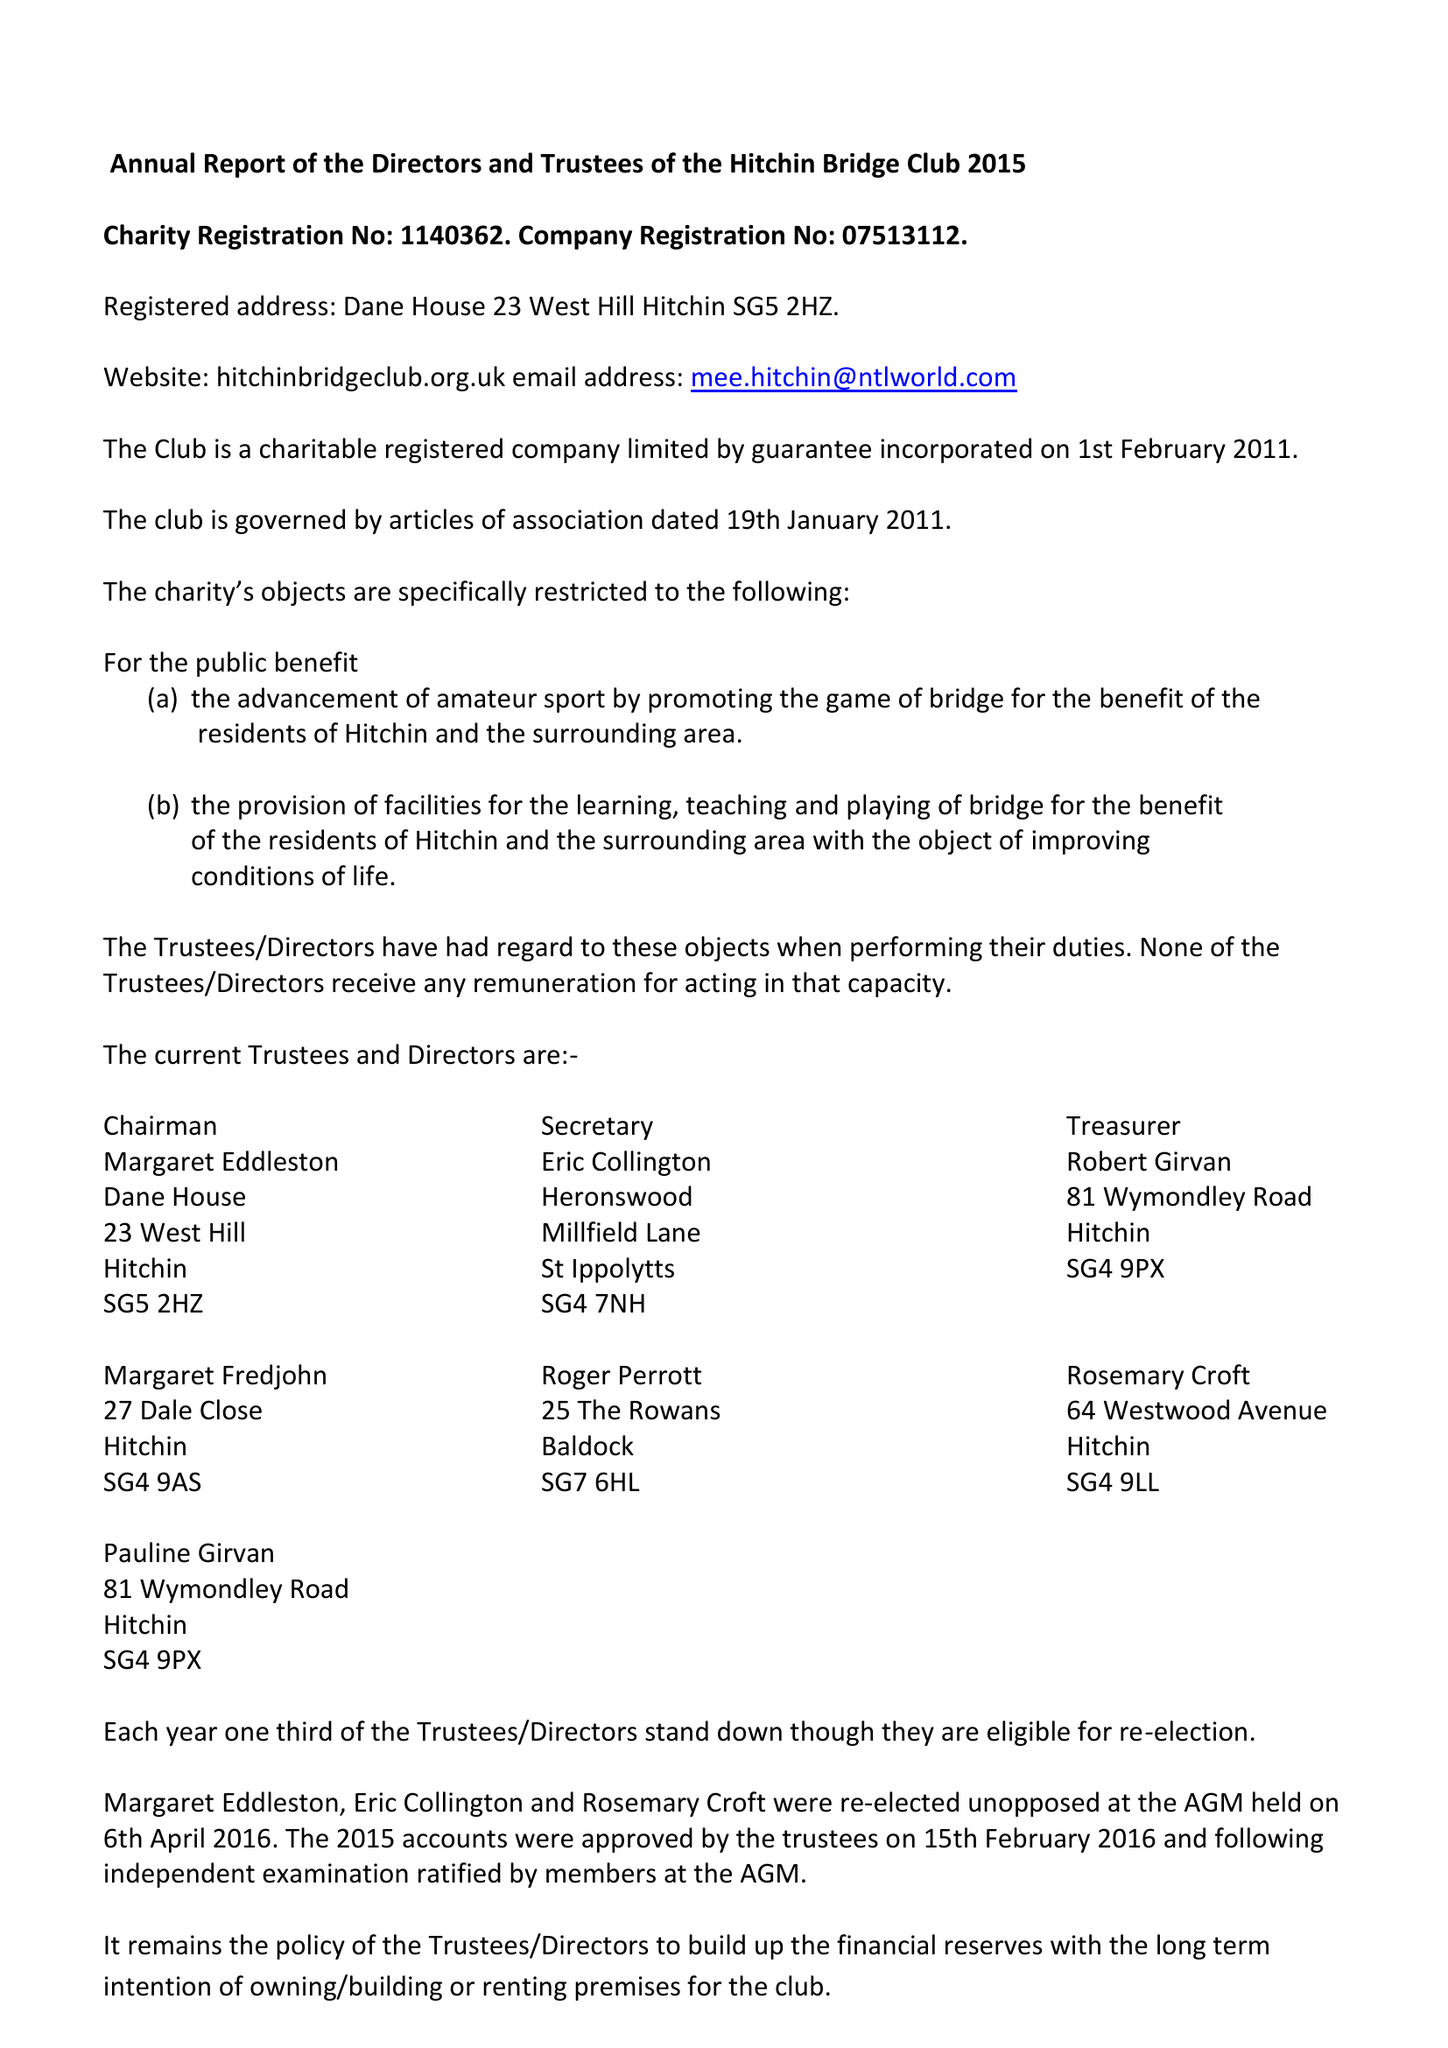What is the value for the charity_number?
Answer the question using a single word or phrase. 1140362 